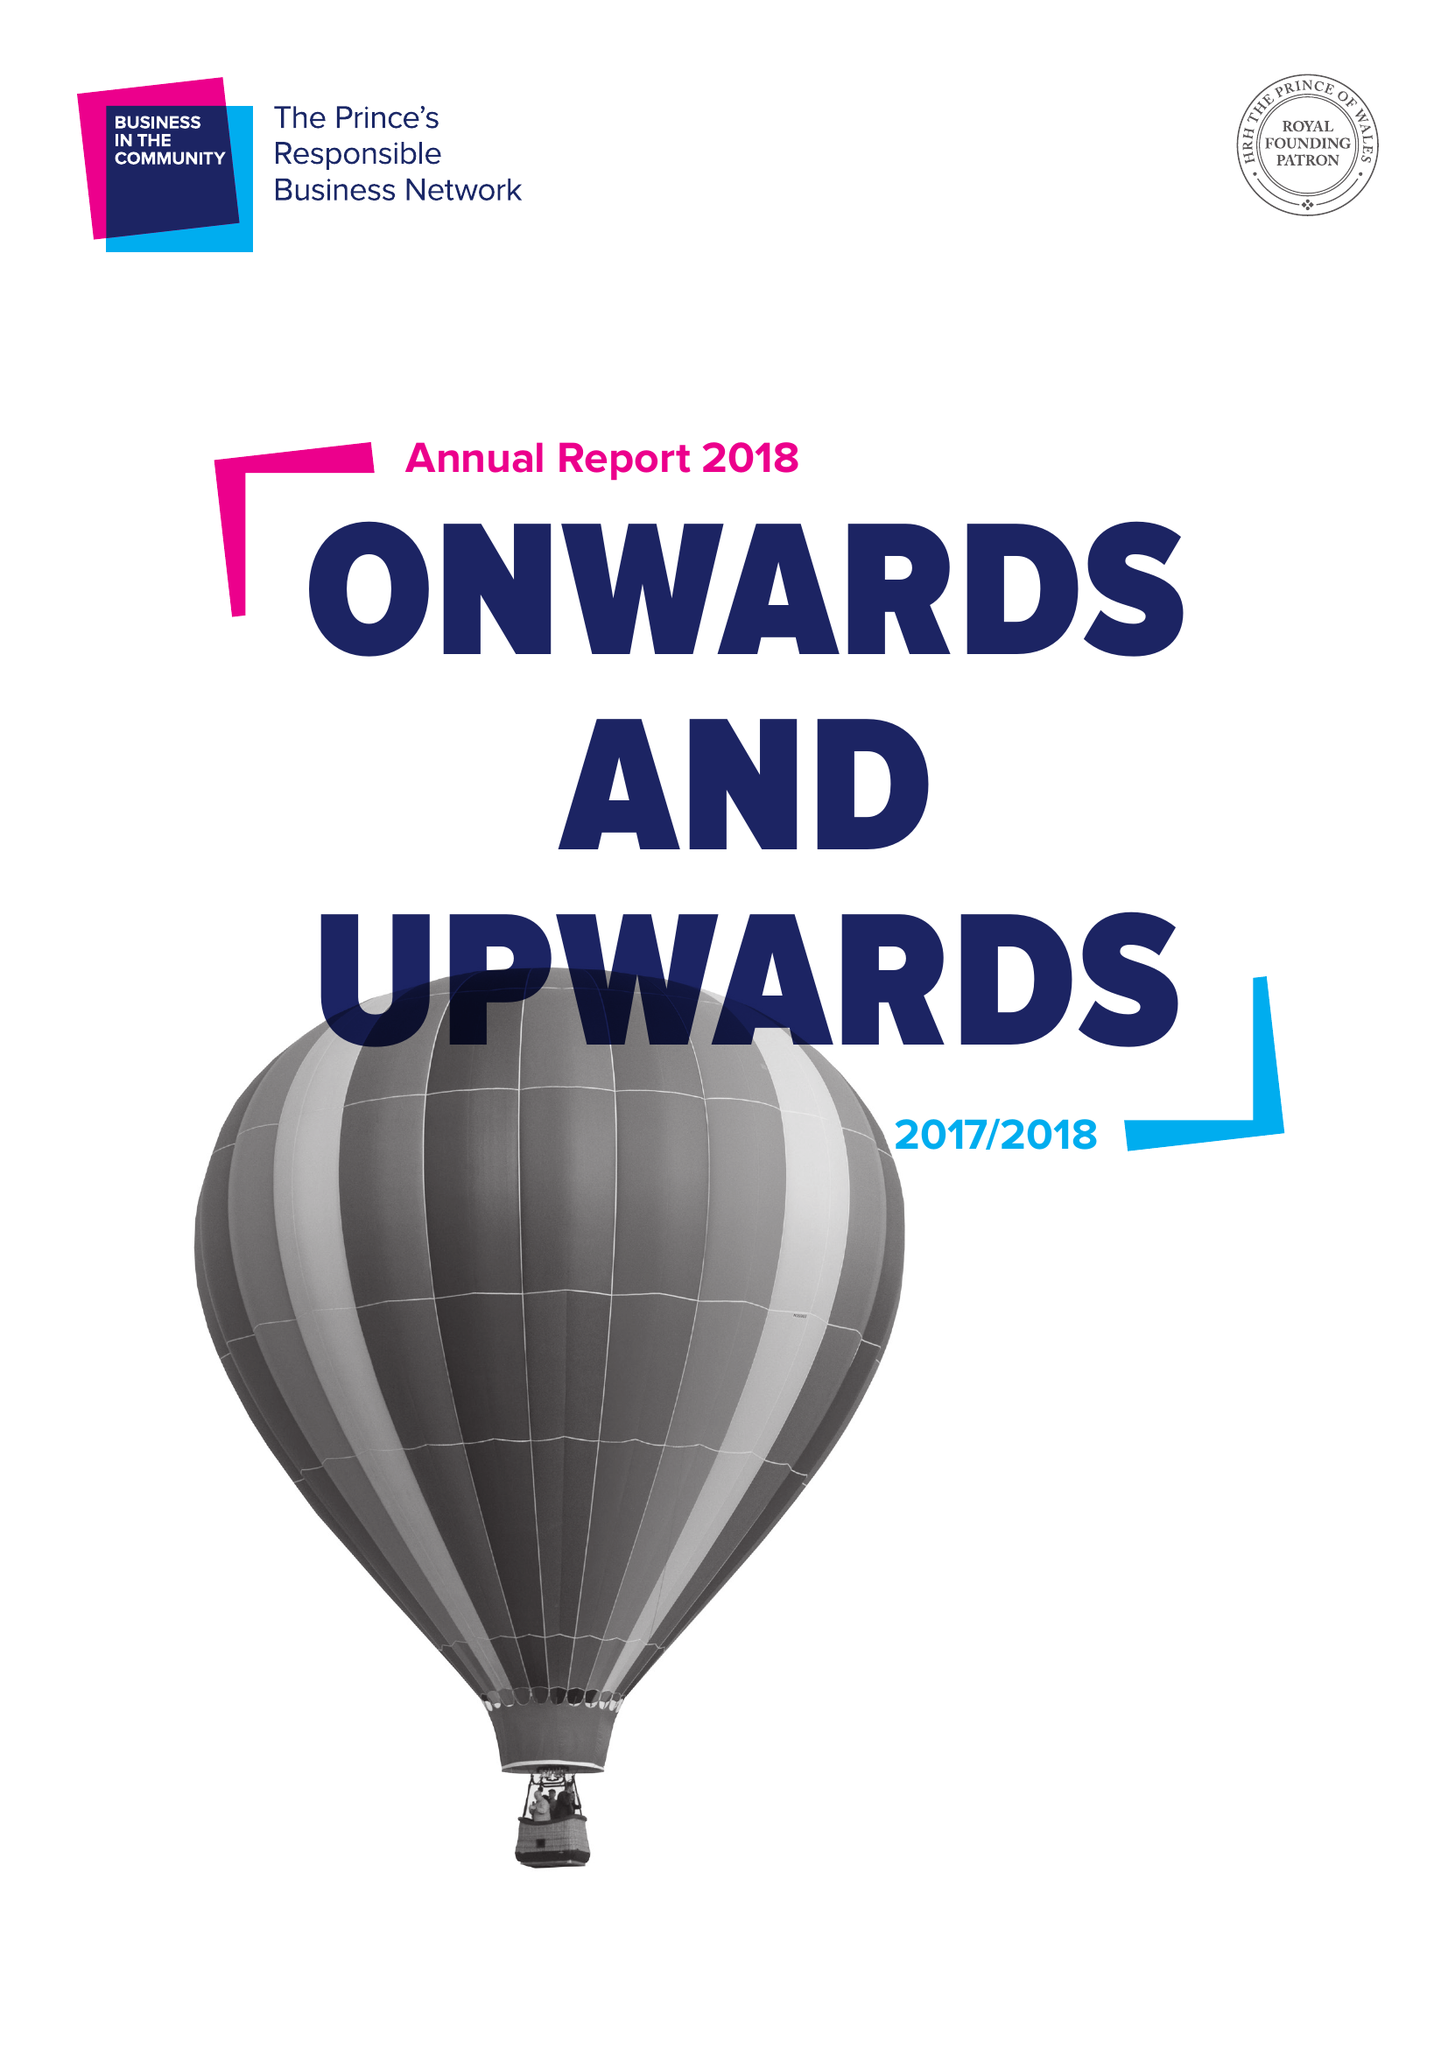What is the value for the charity_number?
Answer the question using a single word or phrase. 297716 